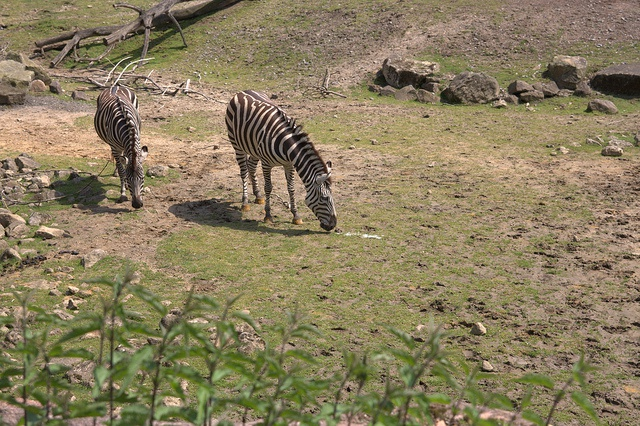Describe the objects in this image and their specific colors. I can see zebra in olive, black, and gray tones and zebra in olive, black, and gray tones in this image. 